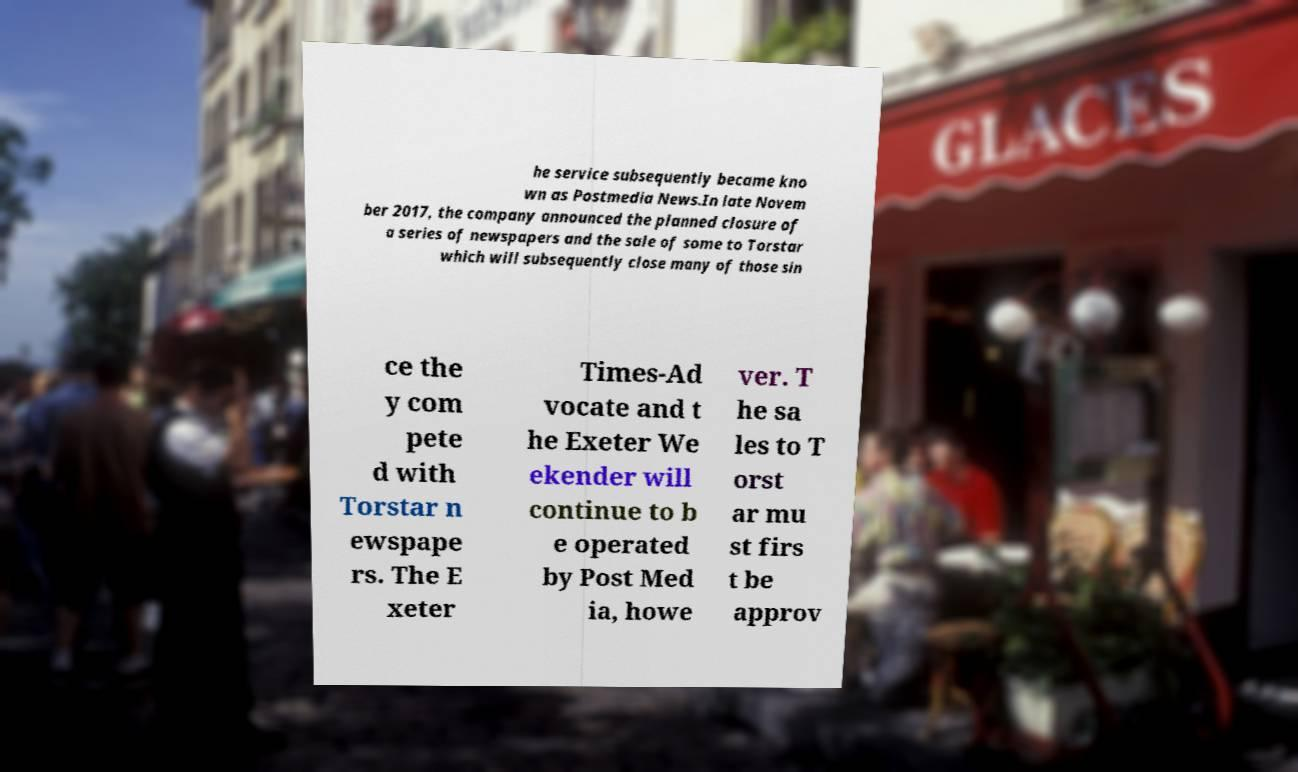I need the written content from this picture converted into text. Can you do that? he service subsequently became kno wn as Postmedia News.In late Novem ber 2017, the company announced the planned closure of a series of newspapers and the sale of some to Torstar which will subsequently close many of those sin ce the y com pete d with Torstar n ewspape rs. The E xeter Times-Ad vocate and t he Exeter We ekender will continue to b e operated by Post Med ia, howe ver. T he sa les to T orst ar mu st firs t be approv 